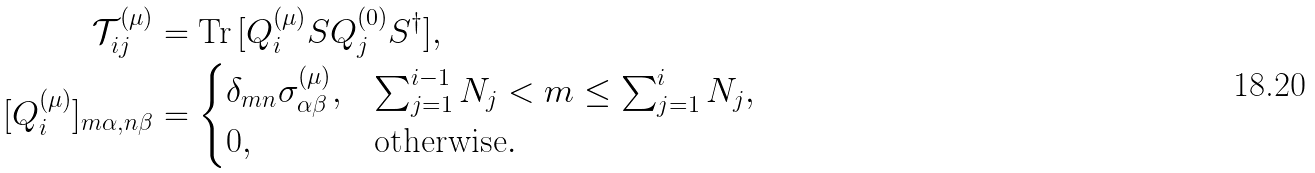Convert formula to latex. <formula><loc_0><loc_0><loc_500><loc_500>\mathcal { T } _ { i j } ^ { ( \mu ) } & = \text {Tr} \, [ Q _ { i } ^ { ( \mu ) } S Q _ { j } ^ { ( 0 ) } S ^ { \dagger } ] , \\ [ Q _ { i } ^ { ( \mu ) } ] _ { m \alpha , n \beta } & = \begin{cases} \delta _ { m n } \sigma ^ { ( \mu ) } _ { \alpha \beta } , & \sum _ { j = 1 } ^ { i - 1 } N _ { j } < m \leq \sum _ { j = 1 } ^ { i } N _ { j } , \\ 0 , & \text {otherwise} . \end{cases}</formula> 